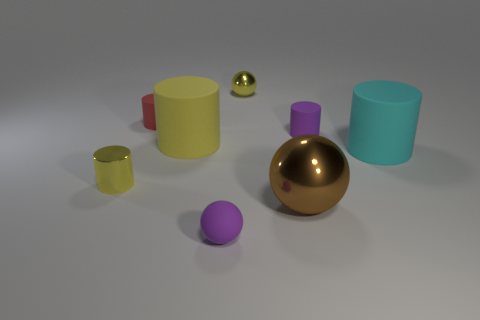Subtract all big cylinders. How many cylinders are left? 3 Add 1 large cyan metal spheres. How many objects exist? 9 Subtract all purple balls. How many balls are left? 2 Subtract 3 cylinders. How many cylinders are left? 2 Subtract 1 purple balls. How many objects are left? 7 Subtract all balls. How many objects are left? 5 Subtract all cyan cylinders. Subtract all cyan spheres. How many cylinders are left? 4 Subtract all green cubes. How many gray balls are left? 0 Subtract all small yellow balls. Subtract all tiny objects. How many objects are left? 2 Add 4 yellow objects. How many yellow objects are left? 7 